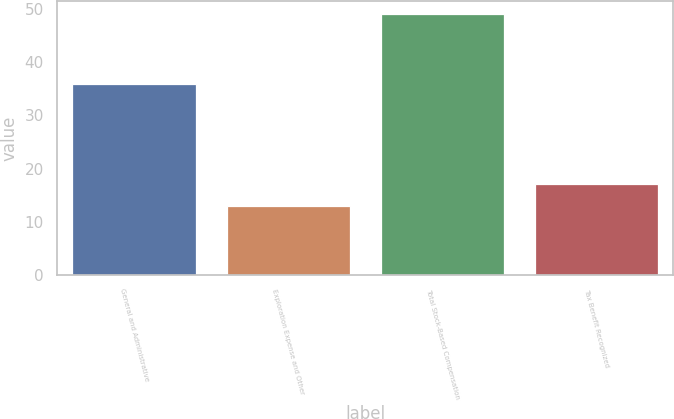<chart> <loc_0><loc_0><loc_500><loc_500><bar_chart><fcel>General and Administrative<fcel>Exploration Expense and Other<fcel>Total Stock-Based Compensation<fcel>Tax Benefit Recognized<nl><fcel>36<fcel>13<fcel>49<fcel>17<nl></chart> 